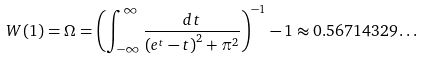Convert formula to latex. <formula><loc_0><loc_0><loc_500><loc_500>W ( 1 ) = \Omega = \left ( \int _ { - \infty } ^ { \infty } { \frac { d t } { \left ( e ^ { t } - t \right ) ^ { 2 } + \pi ^ { 2 } } } \right ) ^ { - 1 } - 1 \approx 0 . 5 6 7 1 4 3 2 9 \dots</formula> 